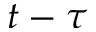<formula> <loc_0><loc_0><loc_500><loc_500>t - \tau</formula> 